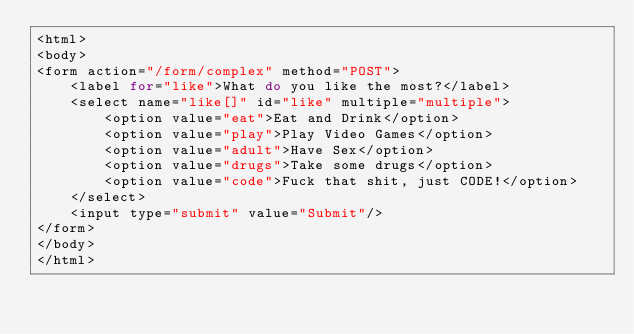Convert code to text. <code><loc_0><loc_0><loc_500><loc_500><_PHP_><html>
<body>
<form action="/form/complex" method="POST">
    <label for="like">What do you like the most?</label>
    <select name="like[]" id="like" multiple="multiple">
        <option value="eat">Eat and Drink</option>
        <option value="play">Play Video Games</option>
        <option value="adult">Have Sex</option>
        <option value="drugs">Take some drugs</option>
        <option value="code">Fuck that shit, just CODE!</option>
    </select>
    <input type="submit" value="Submit"/>
</form>
</body>
</html></code> 